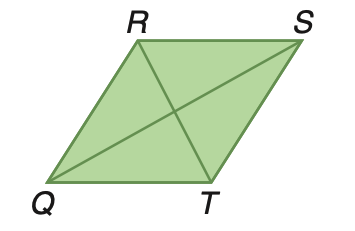Question: Rhombus Q R S T has an area of 137.9 square meters. If R T is 12.2 meters, find Q S.
Choices:
A. 11.3
B. 22.4
C. 22.6
D. 25.6
Answer with the letter. Answer: C 